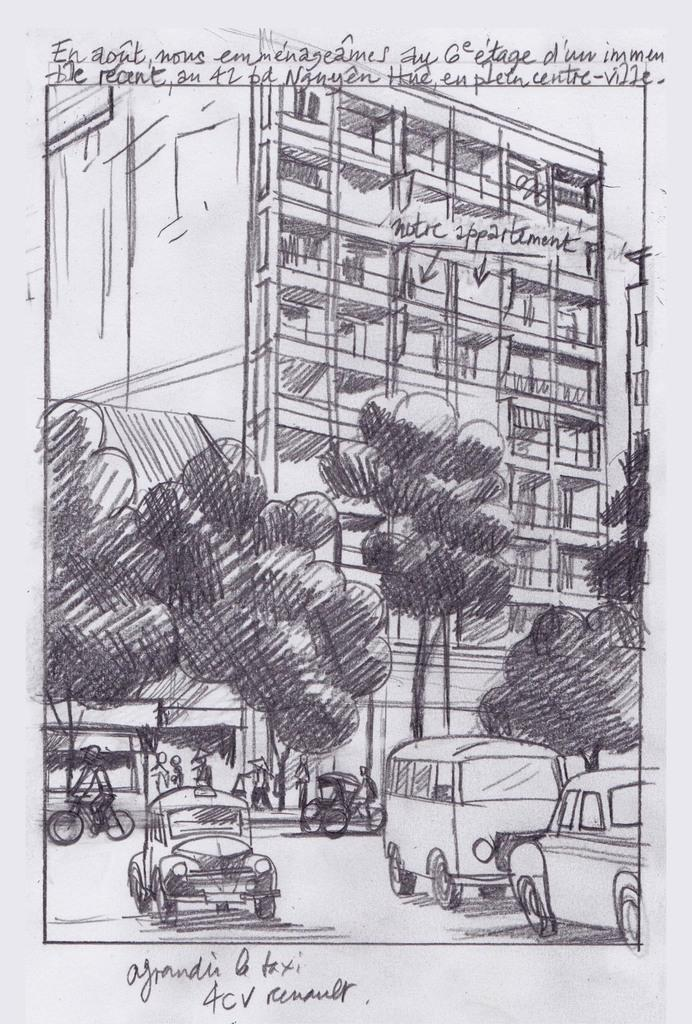What is the main subject of the image? There is an art piece in the image. Can you describe any additional features of the image? There is text visible in the image. How many cows are present in the image? There are no cows present in the image; it features an art piece and text. What type of cream is being used in the image? There is no cream present in the image. 